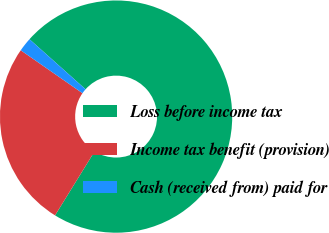Convert chart to OTSL. <chart><loc_0><loc_0><loc_500><loc_500><pie_chart><fcel>Loss before income tax<fcel>Income tax benefit (provision)<fcel>Cash (received from) paid for<nl><fcel>72.2%<fcel>25.86%<fcel>1.93%<nl></chart> 